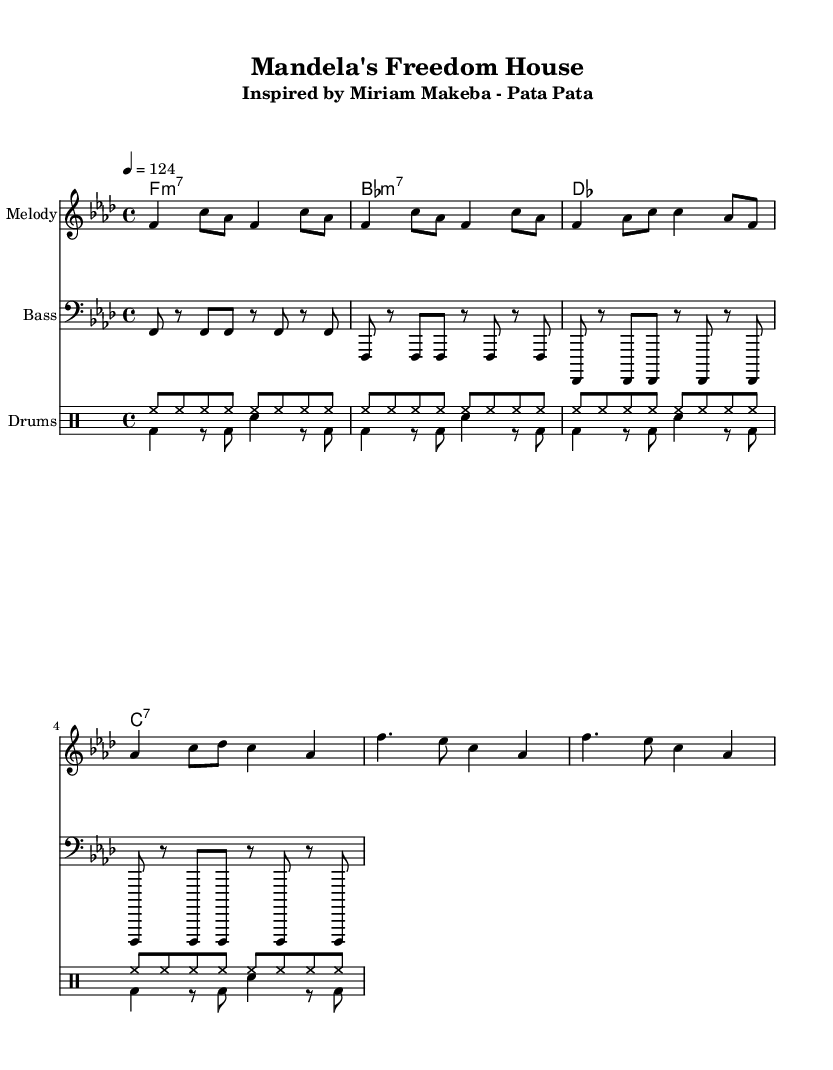What is the key signature of this music? The key signature is F minor, which consists of four flats (B♭, E♭, A♭, D♭). You can tell by looking at the key signature indicated at the beginning of the staff.
Answer: F minor What is the time signature of this piece? The time signature is 4/4, which means there are four beats per measure and the quarter note gets one beat. This is indicated at the beginning of the sheet music.
Answer: 4/4 What is the tempo marking indicated in the music? The tempo marking is 124, which tells the performer to play at this beats per minute (BPM). It is indicated in the tempo section at the start of the piece: "4 = 124".
Answer: 124 How many measures are in the melody section? The melody section includes 8 measures; you can count the vertical lines (bar lines) that separate each measure, noting there are 8 before any repeats or new sections.
Answer: 8 What type of chord is the first chord in the harmonic progression? The first chord indicated is an F minor seventh chord, denoted as "f1:m7". This signifies the chord is based on F and includes the minor seventh.
Answer: F:m7 What instruments are included in this arrangement? The arrangement includes melody, bass, and drums, as indicated by the titles above each staff: "Melody", "Bass", and "Drums".
Answer: Melody, Bass, Drums How does the bass line primarily move throughout the piece? The bass line primarily moves in repeated quarter notes, creating a steady rhythmic foundation. Observing the repeated notes and their durations indicates a consistent pattern with emphasis on F.
Answer: Repeated quarter notes 